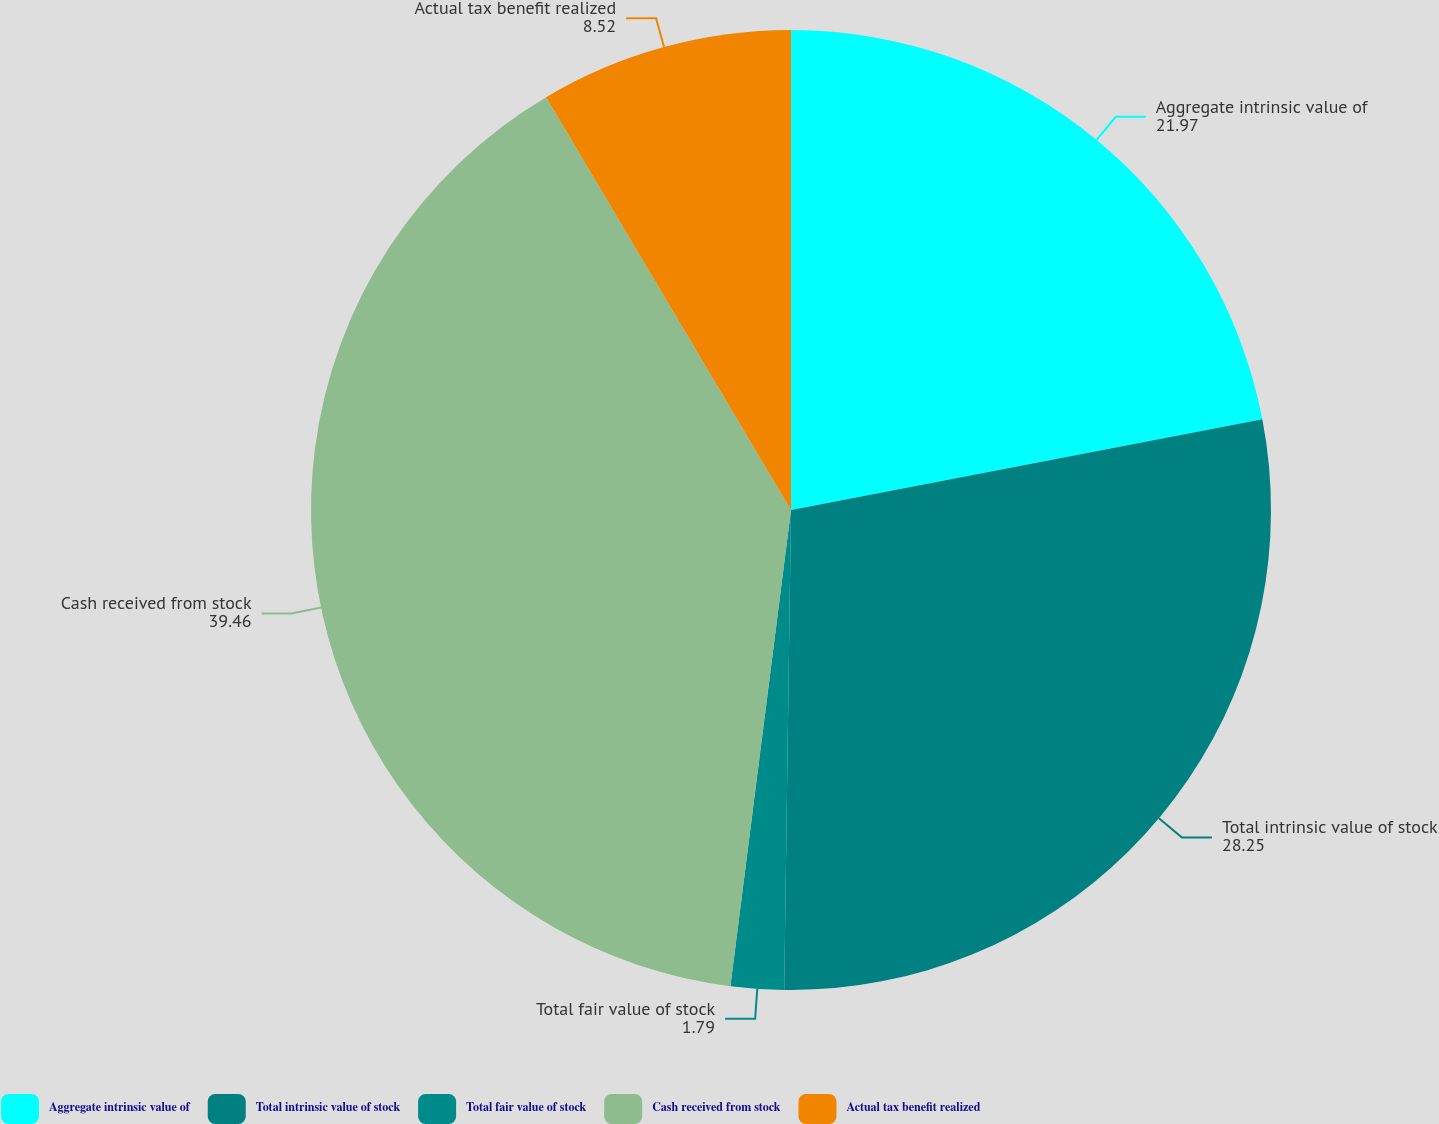Convert chart. <chart><loc_0><loc_0><loc_500><loc_500><pie_chart><fcel>Aggregate intrinsic value of<fcel>Total intrinsic value of stock<fcel>Total fair value of stock<fcel>Cash received from stock<fcel>Actual tax benefit realized<nl><fcel>21.97%<fcel>28.25%<fcel>1.79%<fcel>39.46%<fcel>8.52%<nl></chart> 